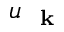Convert formula to latex. <formula><loc_0><loc_0><loc_500><loc_500>u _ { k }</formula> 